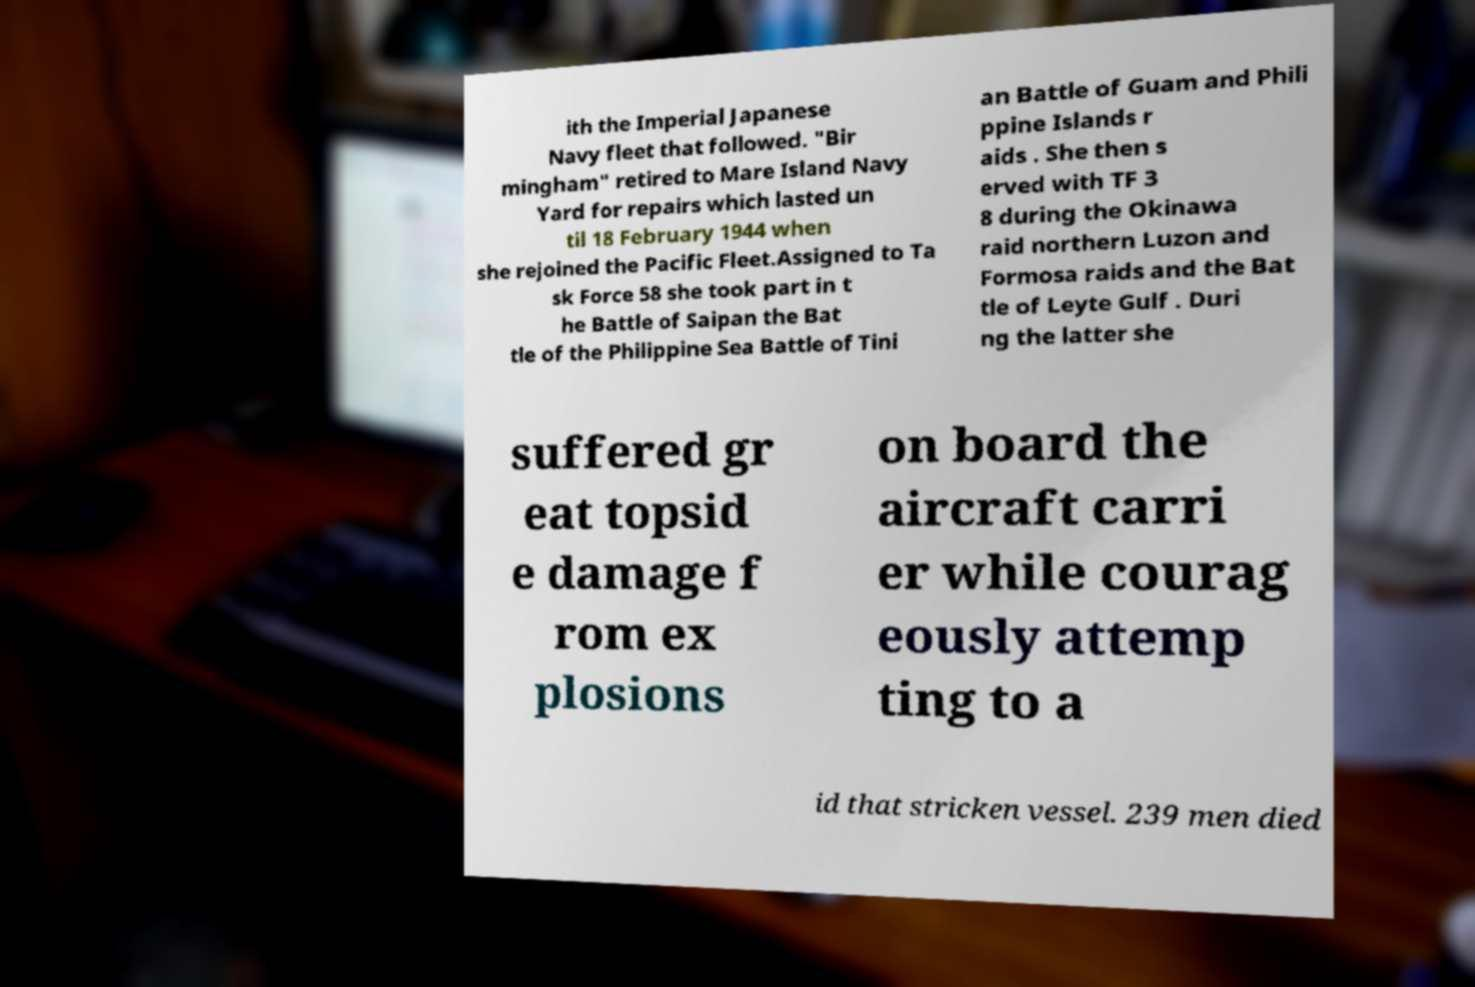What messages or text are displayed in this image? I need them in a readable, typed format. ith the Imperial Japanese Navy fleet that followed. "Bir mingham" retired to Mare Island Navy Yard for repairs which lasted un til 18 February 1944 when she rejoined the Pacific Fleet.Assigned to Ta sk Force 58 she took part in t he Battle of Saipan the Bat tle of the Philippine Sea Battle of Tini an Battle of Guam and Phili ppine Islands r aids . She then s erved with TF 3 8 during the Okinawa raid northern Luzon and Formosa raids and the Bat tle of Leyte Gulf . Duri ng the latter she suffered gr eat topsid e damage f rom ex plosions on board the aircraft carri er while courag eously attemp ting to a id that stricken vessel. 239 men died 